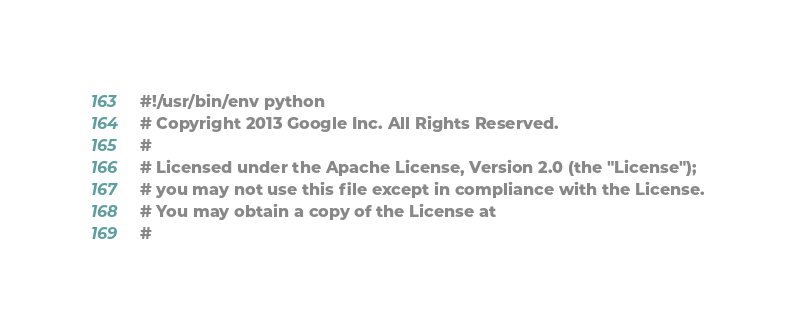<code> <loc_0><loc_0><loc_500><loc_500><_Python_>#!/usr/bin/env python
# Copyright 2013 Google Inc. All Rights Reserved.
#
# Licensed under the Apache License, Version 2.0 (the "License");
# you may not use this file except in compliance with the License.
# You may obtain a copy of the License at
#</code> 